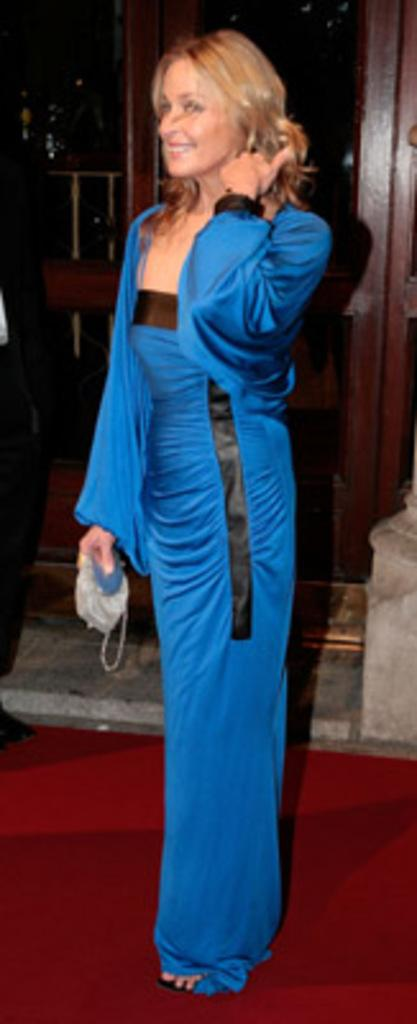What is the woman doing in the image? The woman is standing and smiling in the image. What is the woman holding in the image? The woman is holding something, but the specific object is not mentioned in the facts. What is the woman wearing in the image? The woman is wearing a blue dress in the image. What type of thread is the woman using to sew in the image? There is no thread or sewing activity present in the image. Can you tell me what type of pipe the woman is holding in the image? There is no pipe present in the image; the woman is holding something, but the specific object is not mentioned in the facts. 